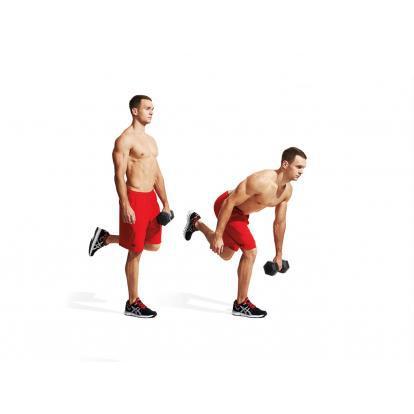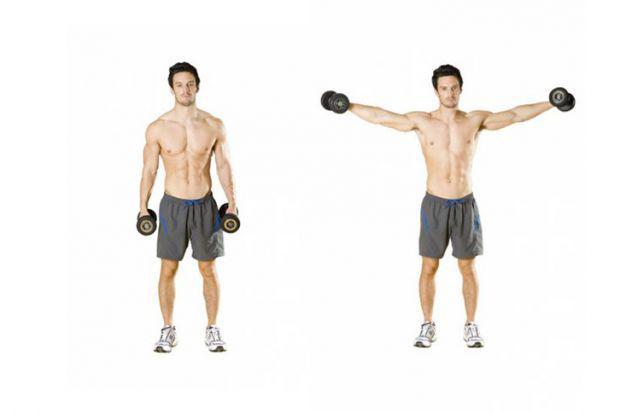The first image is the image on the left, the second image is the image on the right. Given the left and right images, does the statement "One image shows a man in a blue shirt doing exercises with weights, while the other image shows a shirtless man in blue shorts doing exercises with weights" hold true? Answer yes or no. No. 